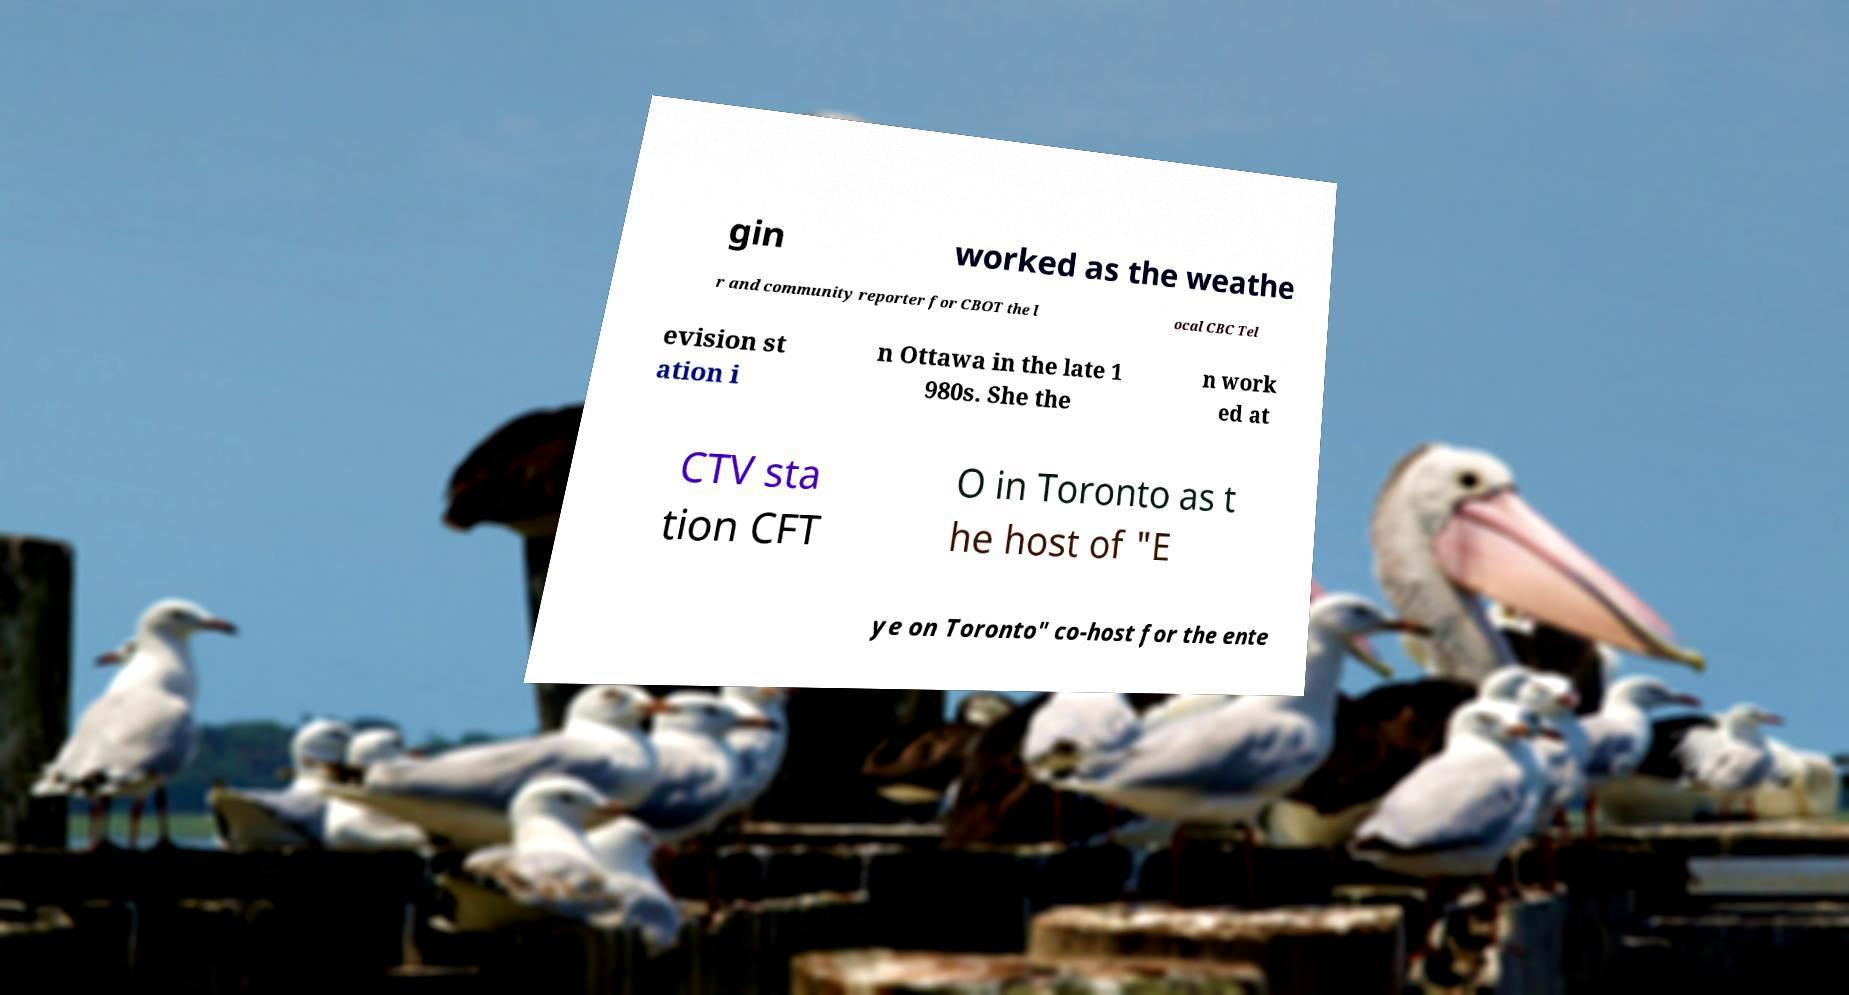Could you assist in decoding the text presented in this image and type it out clearly? gin worked as the weathe r and community reporter for CBOT the l ocal CBC Tel evision st ation i n Ottawa in the late 1 980s. She the n work ed at CTV sta tion CFT O in Toronto as t he host of "E ye on Toronto" co-host for the ente 